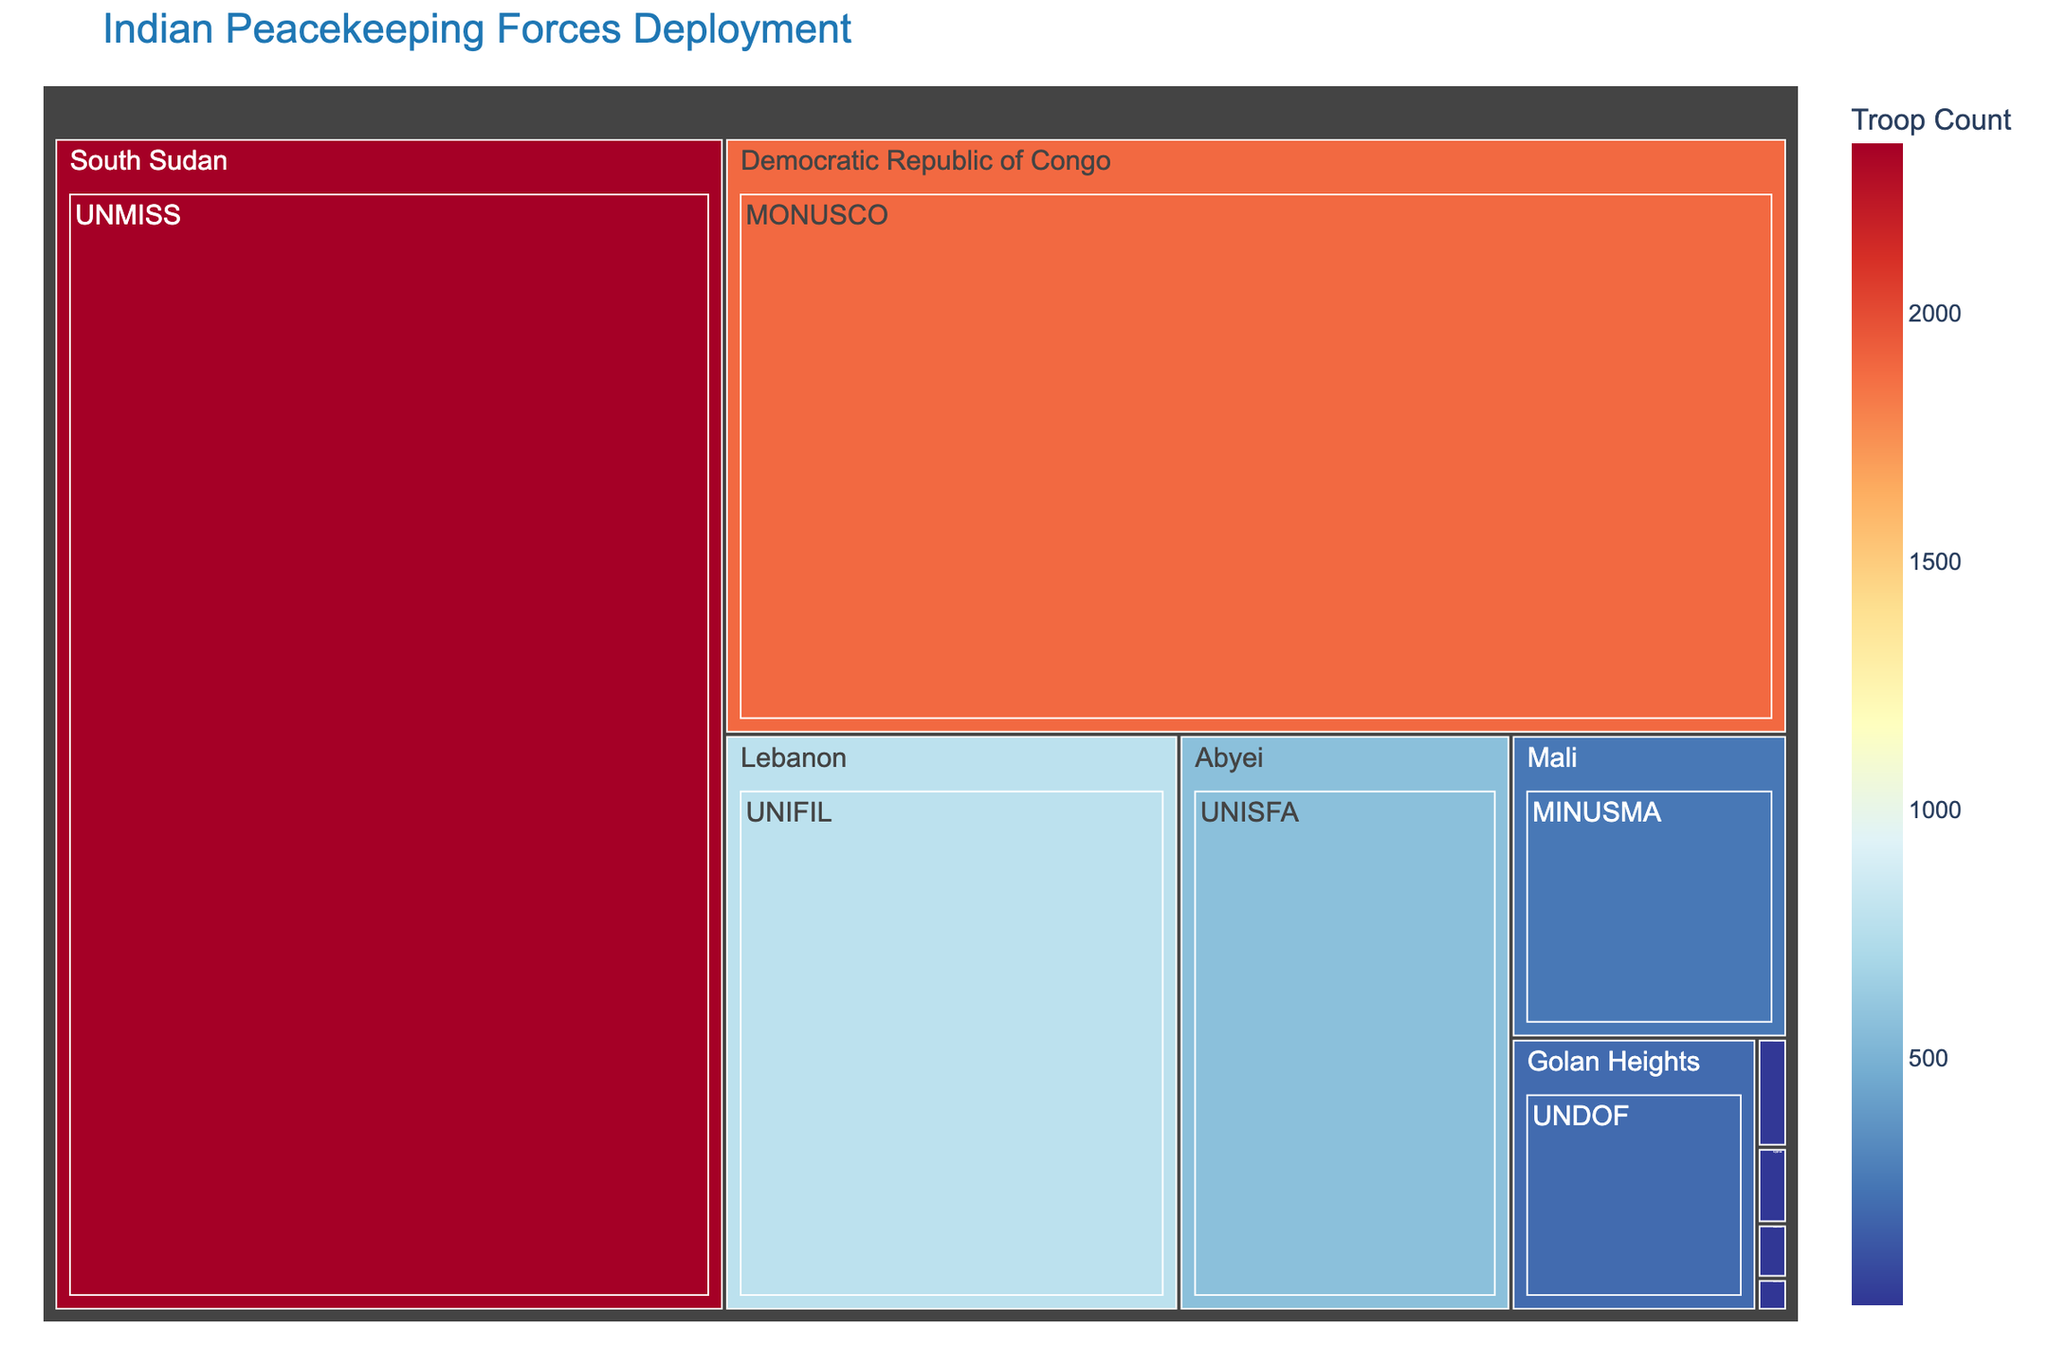Which mission has the highest troop count? The figure shows the regions and missions with the troop count color-coded by the depth of color. The mission with the deepest color and the largest area corresponds to the highest troop count. UNMISS in South Sudan has the highest troop count.
Answer: UNMISS Which mission has the lowest troop count? By identifying the mission with the smallest colored area and lightest hue in the treemap, the mission with the lowest troop count can be found. MINURSO in Western Sahara has the lowest troop count.
Answer: MINURSO How many troops are deployed in Lebanon? By looking at the section of the treemap labeled "Lebanon", the troop count for the UNIFIL mission can be identified. The troop count for UNIFIL in Lebanon is displayed as 780.
Answer: 780 What is the total number of troops deployed in Africa? The total number of troops deployed in Africa includes troops in South Sudan (UNMISS), Democratic Republic of Congo (MONUSCO), Mali (MINUSMA), Abyei (UNISFA). Adding these, 2342 (UNMISS) + 1888 (MONUSCO) + 250 (MINUSMA) + 570 (UNISFA) equals 5050.
Answer: 5050 Which region has the second highest troop count? The second largest area in the treemap after "South Sudan" corresponds to the "Democratic Republic of Congo" with the MONUSCO mission and 1888 troops.
Answer: Democratic Republic of Congo Compare the troop counts of UNDOF and UNMOGIP. UNDOF in the Golan Heights has a troop count of 200, whereas UNMOGIP on the India–Pakistan border has a troop count of 10. 200 is greater than 10, so more troops are deployed for UNDOF.
Answer: UNDOF has more troops deployed What is the combined troop count for UNFICYP and UNTSO? The troop counts for UNFICYP (Cyprus) and UNTSO (Middle East) are 7 and 5, respectively. Adding these two, 7 + 5 equals 12.
Answer: 12 Which mission in Africa has the lowest troop count? Among the missions in Africa, the one with the smallest area that represents the lowest troop count is MINUSMA in Mali with 250 troops.
Answer: MINUSMA How many missions are represented in the Middle East region? By looking at the treemap, the regions labeled "Middle East" include UNTSO and UNDOF, which means there are 2 missions in the Middle East.
Answer: 2 